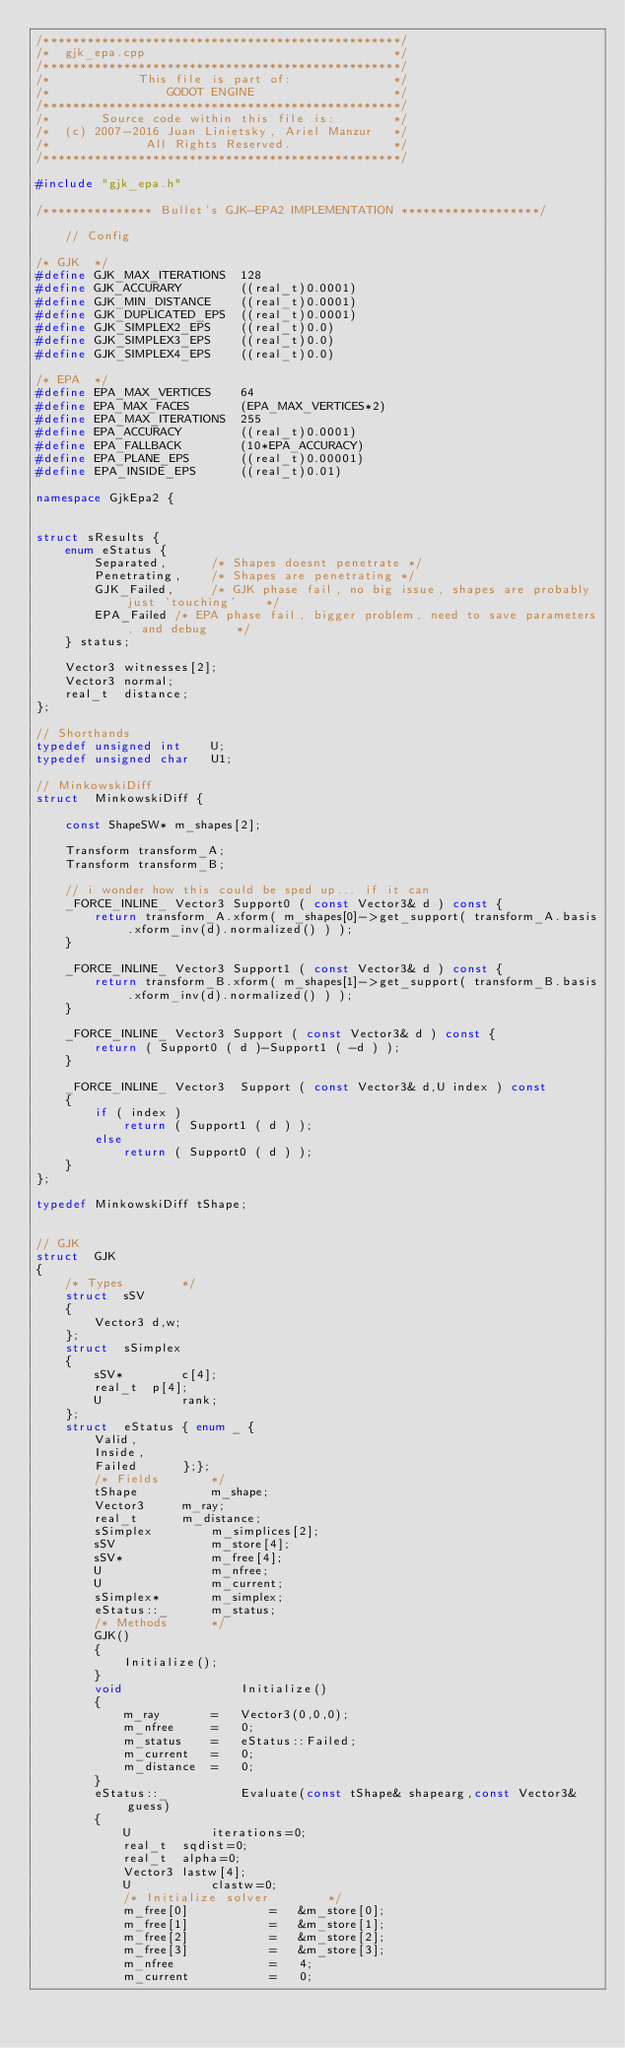Convert code to text. <code><loc_0><loc_0><loc_500><loc_500><_C++_>/*************************************************/
/*  gjk_epa.cpp                                  */
/*************************************************/
/*            This file is part of:              */
/*                GODOT ENGINE                   */
/*************************************************/
/*       Source code within this file is:        */
/*  (c) 2007-2016 Juan Linietsky, Ariel Manzur   */
/*             All Rights Reserved.              */
/*************************************************/

#include "gjk_epa.h"

/*************** Bullet's GJK-EPA2 IMPLEMENTATION *******************/

	// Config

/* GJK	*/
#define GJK_MAX_ITERATIONS	128
#define GJK_ACCURARY		((real_t)0.0001)
#define GJK_MIN_DISTANCE	((real_t)0.0001)
#define GJK_DUPLICATED_EPS	((real_t)0.0001)
#define GJK_SIMPLEX2_EPS	((real_t)0.0)
#define GJK_SIMPLEX3_EPS	((real_t)0.0)
#define GJK_SIMPLEX4_EPS	((real_t)0.0)

/* EPA	*/
#define EPA_MAX_VERTICES	64
#define EPA_MAX_FACES		(EPA_MAX_VERTICES*2)
#define EPA_MAX_ITERATIONS	255
#define EPA_ACCURACY		((real_t)0.0001)
#define EPA_FALLBACK		(10*EPA_ACCURACY)
#define EPA_PLANE_EPS		((real_t)0.00001)
#define EPA_INSIDE_EPS		((real_t)0.01)

namespace GjkEpa2 {


struct sResults	{
	enum eStatus {
		Separated,		/* Shapes doesnt penetrate */
		Penetrating,	/* Shapes are penetrating */
		GJK_Failed,		/* GJK phase fail, no big issue, shapes are probably just 'touching'	*/
		EPA_Failed /* EPA phase fail, bigger problem, need to save parameters, and debug	*/
	} status;

	Vector3	witnesses[2];
	Vector3	normal;
	real_t	distance;
};

// Shorthands
typedef unsigned int	U;
typedef unsigned char	U1;

// MinkowskiDiff
struct	MinkowskiDiff {

	const ShapeSW* m_shapes[2];

	Transform transform_A;
	Transform transform_B;

	// i wonder how this could be sped up... if it can
	_FORCE_INLINE_ Vector3 Support0 ( const Vector3& d ) const {
		return transform_A.xform( m_shapes[0]->get_support( transform_A.basis.xform_inv(d).normalized() ) );
	}

	_FORCE_INLINE_ Vector3 Support1 ( const Vector3& d ) const {
		return transform_B.xform( m_shapes[1]->get_support( transform_B.basis.xform_inv(d).normalized() ) );
	}

	_FORCE_INLINE_ Vector3 Support ( const Vector3& d ) const {
		return ( Support0 ( d )-Support1 ( -d ) );
	}

	_FORCE_INLINE_ Vector3	Support ( const Vector3& d,U index ) const
	{
		if ( index )
			return ( Support1 ( d ) );
		else
			return ( Support0 ( d ) );
	}
};

typedef	MinkowskiDiff tShape;


// GJK
struct	GJK
{
	/* Types		*/
	struct	sSV
	{
		Vector3	d,w;
	};
	struct	sSimplex
	{
		sSV*		c[4];
		real_t	p[4];
		U			rank;
	};
	struct	eStatus	{ enum _ {
		Valid,
		Inside,
		Failed		};};
		/* Fields		*/
		tShape			m_shape;
		Vector3		m_ray;
		real_t		m_distance;
		sSimplex		m_simplices[2];
		sSV				m_store[4];
		sSV*			m_free[4];
		U				m_nfree;
		U				m_current;
		sSimplex*		m_simplex;
		eStatus::_		m_status;
		/* Methods		*/
		GJK()
		{
			Initialize();
		}
		void				Initialize()
		{
			m_ray		=	Vector3(0,0,0);
			m_nfree		=	0;
			m_status	=	eStatus::Failed;
			m_current	=	0;
			m_distance	=	0;
		}
		eStatus::_			Evaluate(const tShape& shapearg,const Vector3& guess)
		{
			U			iterations=0;
			real_t	sqdist=0;
			real_t	alpha=0;
			Vector3	lastw[4];
			U			clastw=0;
			/* Initialize solver		*/
			m_free[0]			=	&m_store[0];
			m_free[1]			=	&m_store[1];
			m_free[2]			=	&m_store[2];
			m_free[3]			=	&m_store[3];
			m_nfree				=	4;
			m_current			=	0;</code> 